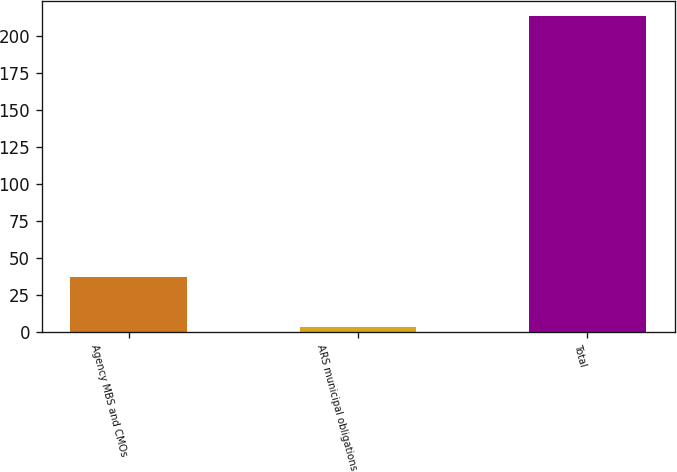Convert chart. <chart><loc_0><loc_0><loc_500><loc_500><bar_chart><fcel>Agency MBS and CMOs<fcel>ARS municipal obligations<fcel>Total<nl><fcel>37<fcel>3<fcel>213<nl></chart> 